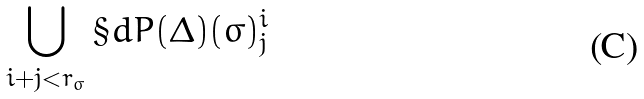<formula> <loc_0><loc_0><loc_500><loc_500>\bigcup _ { i + j < r _ { \sigma } } \S d P ( \Delta ) ( \sigma ) _ { j } ^ { i }</formula> 